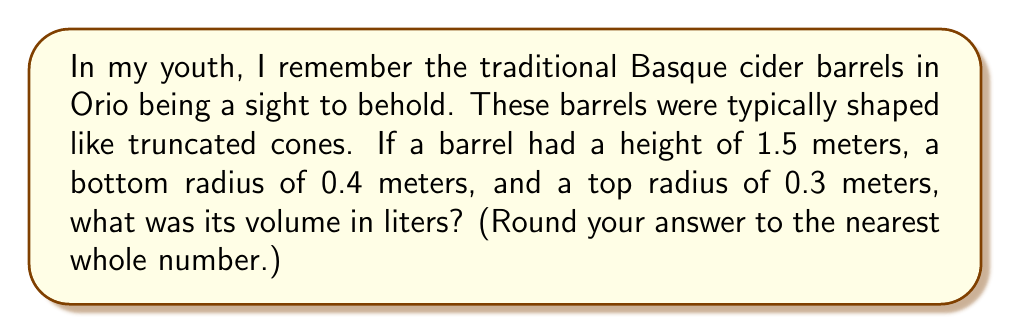Show me your answer to this math problem. To solve this problem, we need to use the formula for the volume of a truncated cone. The steps are as follows:

1) The formula for the volume of a truncated cone is:

   $$V = \frac{1}{3}\pi h(R^2 + r^2 + Rr)$$

   Where:
   $V$ is the volume
   $h$ is the height
   $R$ is the radius of the base
   $r$ is the radius of the top

2) We have the following values:
   $h = 1.5$ m
   $R = 0.4$ m
   $r = 0.3$ m

3) Let's substitute these values into our formula:

   $$V = \frac{1}{3}\pi \cdot 1.5(0.4^2 + 0.3^2 + 0.4 \cdot 0.3)$$

4) Now let's calculate step by step:
   $$V = 0.5\pi(0.16 + 0.09 + 0.12)$$
   $$V = 0.5\pi(0.37)$$
   $$V = 0.185\pi$$

5) Calculate this value:
   $$V \approx 0.5811 \text{ m}^3$$

6) Convert cubic meters to liters (1 m³ = 1000 L):
   $$V \approx 581.1 \text{ L}$$

7) Rounding to the nearest whole number:
   $$V \approx 581 \text{ L}$$
Answer: The volume of the traditional Basque cider barrel is approximately 581 liters. 